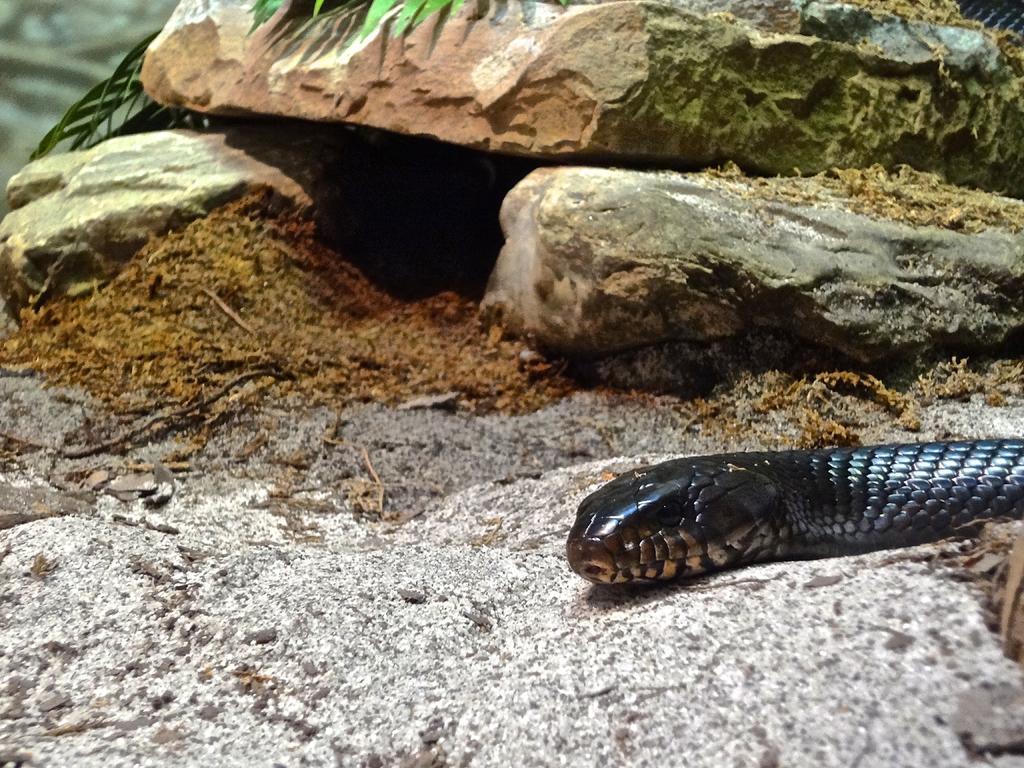Could you give a brief overview of what you see in this image? In this image, on the right side, we can see a snake which is on the land. In the background, we can see some rocks, leaves. At the bottom, we can see a land with some stones. 